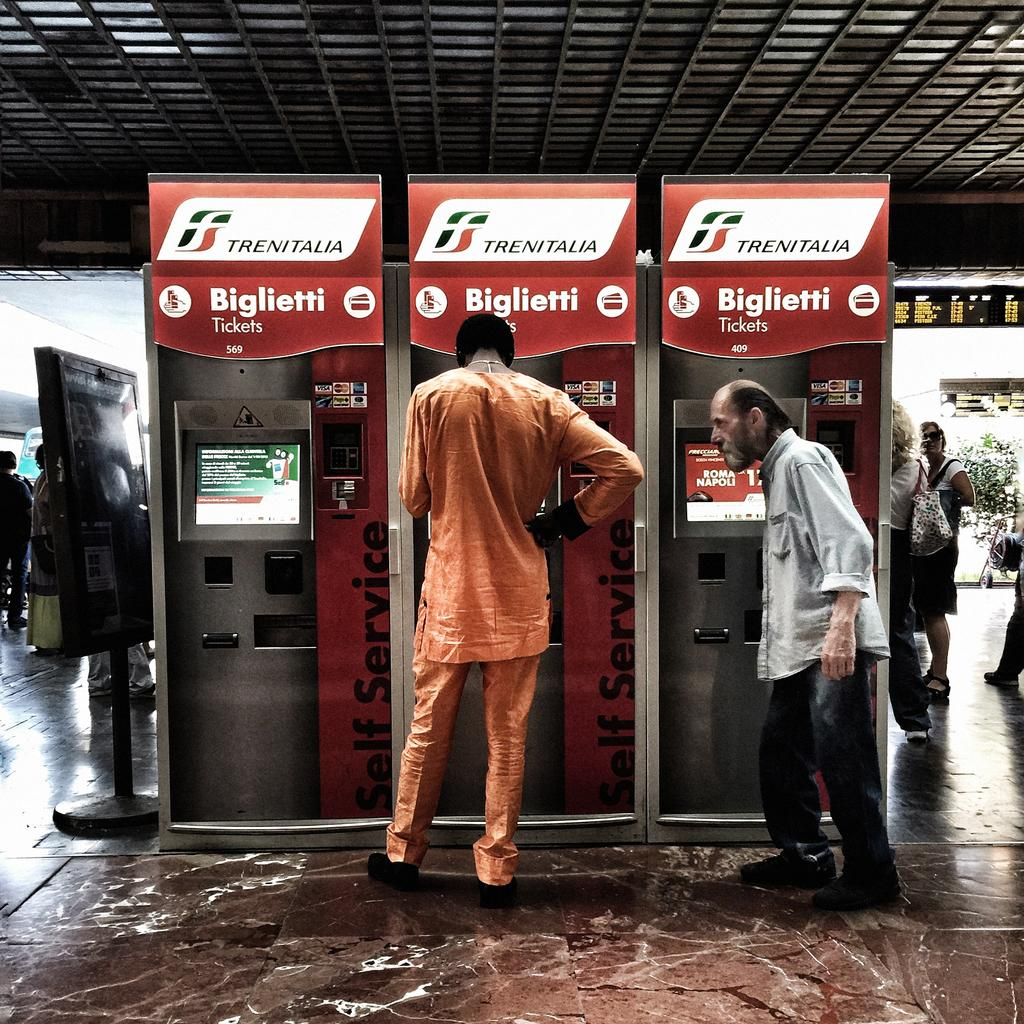What are the people near in the image? The people are standing near ticket counters in the image. What can be seen in the background of the image? There is a roof, plants, persons standing on the floor, information boards, and the floor visible in the background of the image. What type of coat is being worn by the person sitting at the table in the image? There is no table or person sitting at a table present in the image. What is the answer to the question that the person is asking in the image? There is no person asking a question in the image, so there is no answer to provide. 